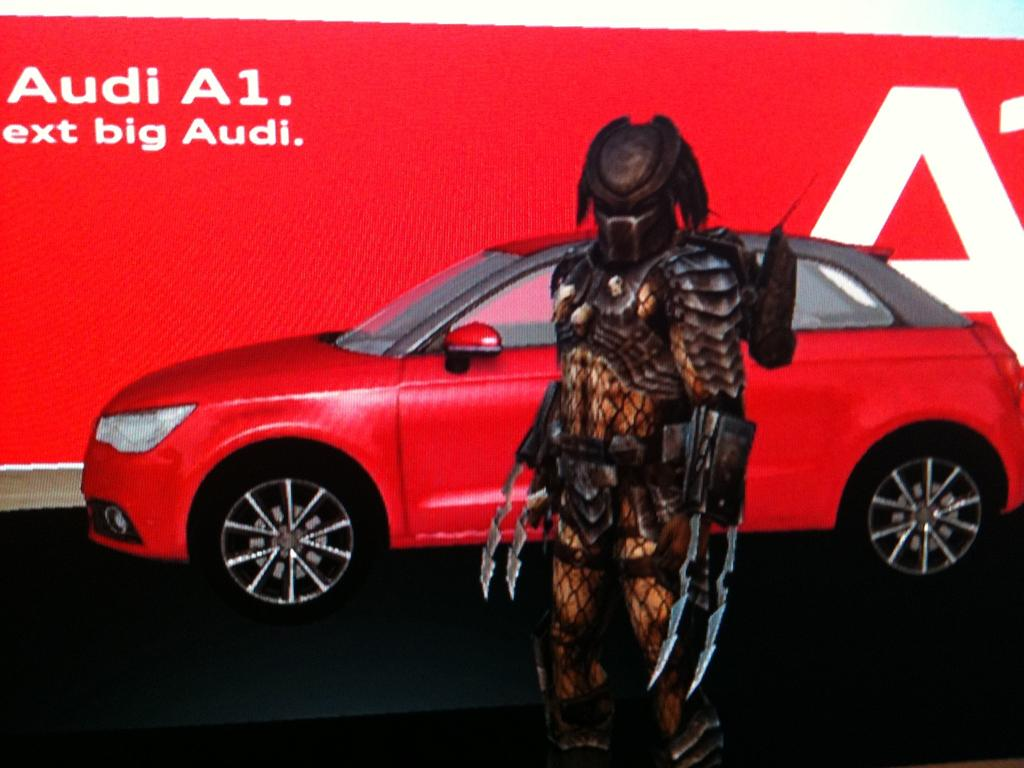What type of image is being described? The image is an animated picture. What vehicle can be seen in the image? There is a car in the image. What other object is present in the image? There is an action figure in the image. What is visible behind the car in the image? There is a hoarding behind the car in the image. How many laborers are working on the pies in the image? There are no laborers or pies present in the image. Is there a ghost visible in the image? There is no ghost visible in the image. 